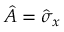Convert formula to latex. <formula><loc_0><loc_0><loc_500><loc_500>\hat { A } = \hat { \sigma } _ { x }</formula> 